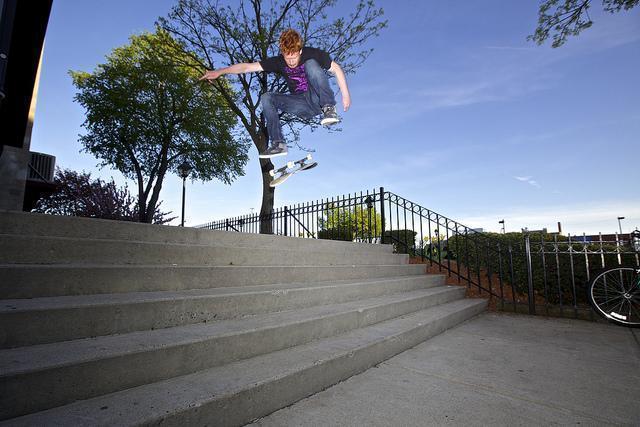If the skateboard kept this orientation how would his landing be?
Pick the correct solution from the four options below to address the question.
Options: Easy, normal, dangerous, soft. Dangerous. 